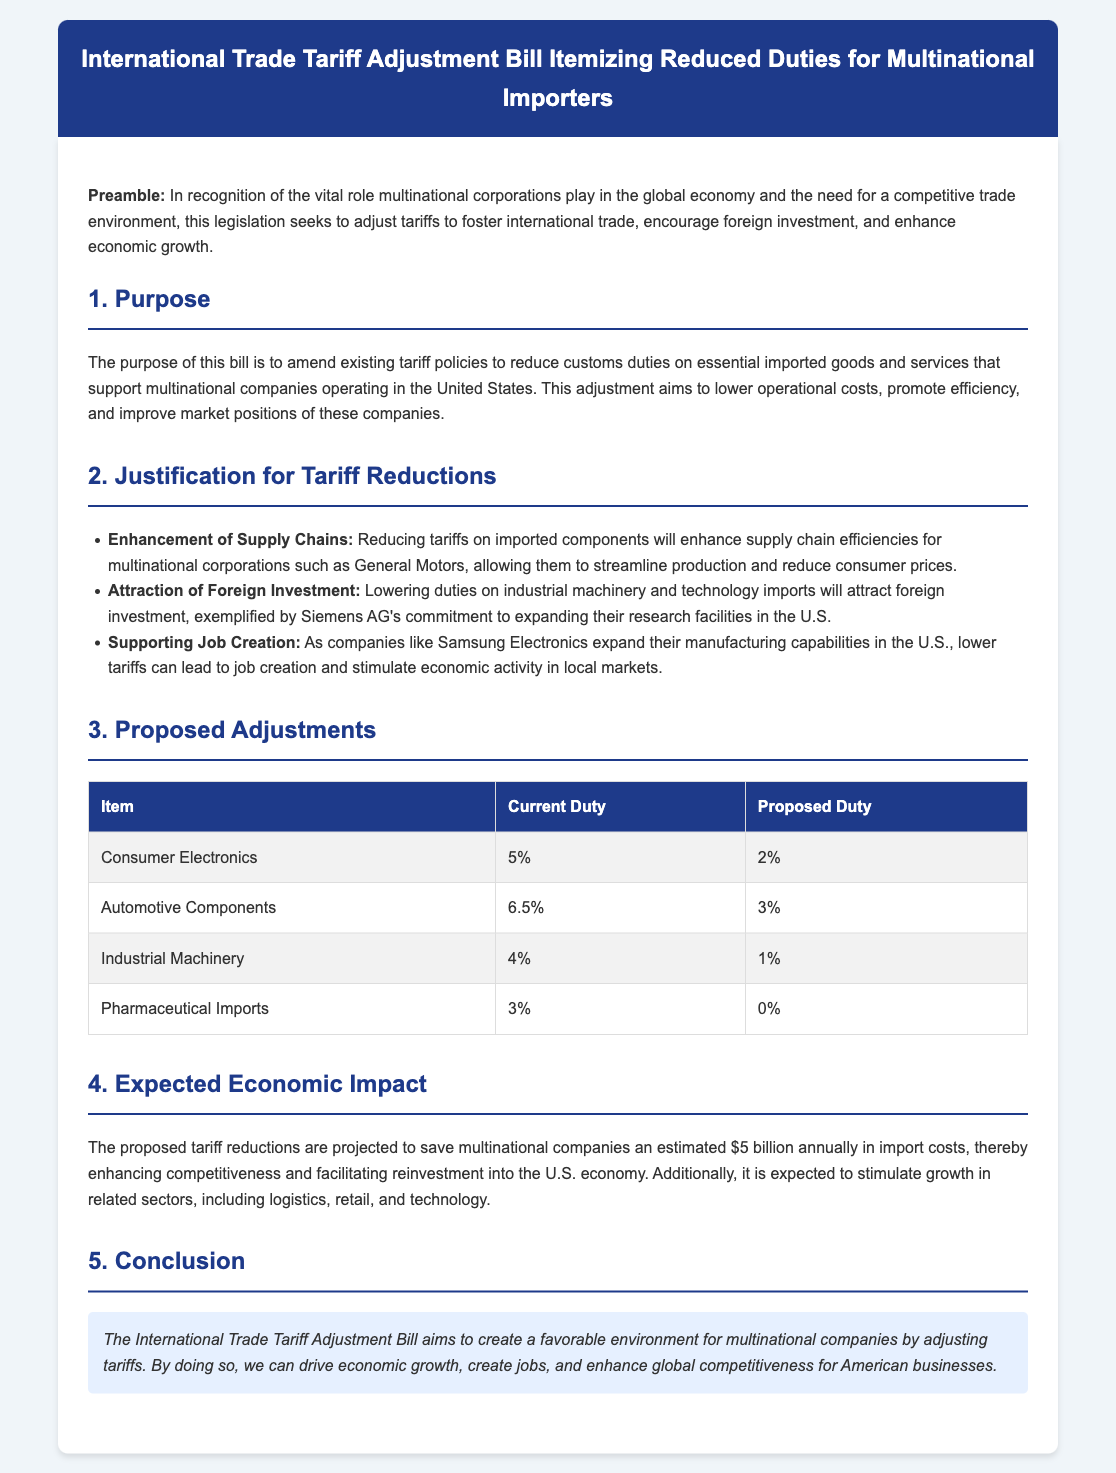What is the title of the bill? The title of the bill is presented prominently at the top of the document.
Answer: International Trade Tariff Adjustment Bill Itemizing Reduced Duties for Multinational Importers What is the current duty on Consumer Electronics? This value is listed in the proposed adjustments table under the Consumer Electronics item.
Answer: 5% What is the proposed duty for Pharmaceutical Imports? This value is found in the proposed adjustments table for the Pharmaceutical Imports item.
Answer: 0% How much is the estimated annual savings for multinational companies? The document states the estimated savings in the section discussing the expected economic impact.
Answer: $5 billion What is the justification for reducing tariffs on industrial machinery? The bill cites a specific reason in the Justification section about attracting foreign investment.
Answer: Attracting foreign investment Which multinational corporation is mentioned in relation to expanding research facilities? The specific corporation is identified in the Justification section of the document.
Answer: Siemens AG What section outlines the purpose of the bill? The Purpose of the bill is discussed in a specific section titled "Purpose."
Answer: 1. Purpose What is the expected impact on related sectors mentioned in the document? This impact is discussed in connection to the estimated economic impact of the proposed adjustments.
Answer: Stimulate growth 